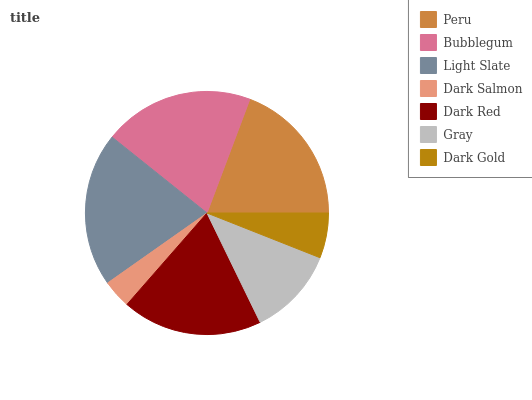Is Dark Salmon the minimum?
Answer yes or no. Yes. Is Light Slate the maximum?
Answer yes or no. Yes. Is Bubblegum the minimum?
Answer yes or no. No. Is Bubblegum the maximum?
Answer yes or no. No. Is Bubblegum greater than Peru?
Answer yes or no. Yes. Is Peru less than Bubblegum?
Answer yes or no. Yes. Is Peru greater than Bubblegum?
Answer yes or no. No. Is Bubblegum less than Peru?
Answer yes or no. No. Is Dark Red the high median?
Answer yes or no. Yes. Is Dark Red the low median?
Answer yes or no. Yes. Is Light Slate the high median?
Answer yes or no. No. Is Dark Salmon the low median?
Answer yes or no. No. 